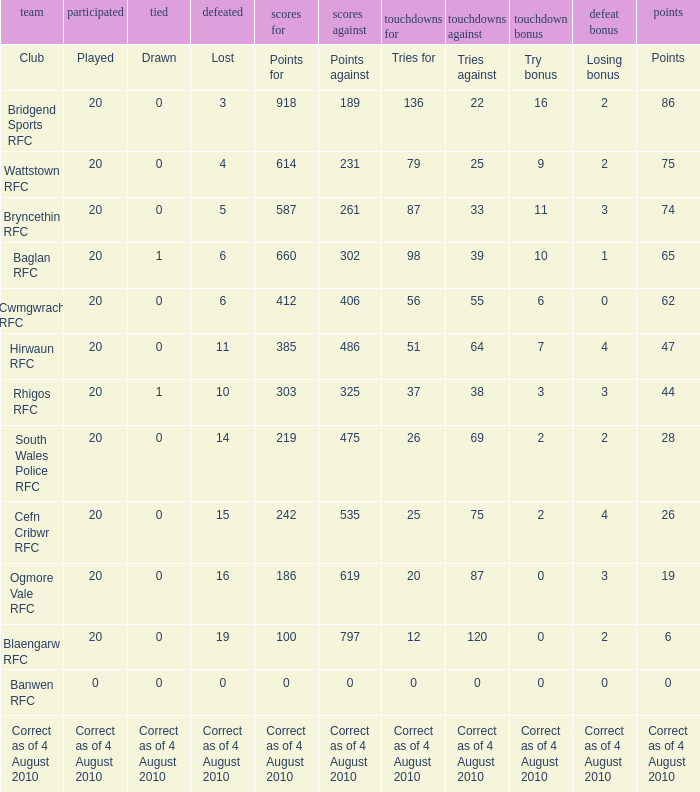Parse the table in full. {'header': ['team', 'participated', 'tied', 'defeated', 'scores for', 'scores against', 'touchdowns for', 'touchdowns against', 'touchdown bonus', 'defeat bonus', 'points'], 'rows': [['Club', 'Played', 'Drawn', 'Lost', 'Points for', 'Points against', 'Tries for', 'Tries against', 'Try bonus', 'Losing bonus', 'Points'], ['Bridgend Sports RFC', '20', '0', '3', '918', '189', '136', '22', '16', '2', '86'], ['Wattstown RFC', '20', '0', '4', '614', '231', '79', '25', '9', '2', '75'], ['Bryncethin RFC', '20', '0', '5', '587', '261', '87', '33', '11', '3', '74'], ['Baglan RFC', '20', '1', '6', '660', '302', '98', '39', '10', '1', '65'], ['Cwmgwrach RFC', '20', '0', '6', '412', '406', '56', '55', '6', '0', '62'], ['Hirwaun RFC', '20', '0', '11', '385', '486', '51', '64', '7', '4', '47'], ['Rhigos RFC', '20', '1', '10', '303', '325', '37', '38', '3', '3', '44'], ['South Wales Police RFC', '20', '0', '14', '219', '475', '26', '69', '2', '2', '28'], ['Cefn Cribwr RFC', '20', '0', '15', '242', '535', '25', '75', '2', '4', '26'], ['Ogmore Vale RFC', '20', '0', '16', '186', '619', '20', '87', '0', '3', '19'], ['Blaengarw RFC', '20', '0', '19', '100', '797', '12', '120', '0', '2', '6'], ['Banwen RFC', '0', '0', '0', '0', '0', '0', '0', '0', '0', '0'], ['Correct as of 4 August 2010', 'Correct as of 4 August 2010', 'Correct as of 4 August 2010', 'Correct as of 4 August 2010', 'Correct as of 4 August 2010', 'Correct as of 4 August 2010', 'Correct as of 4 August 2010', 'Correct as of 4 August 2010', 'Correct as of 4 August 2010', 'Correct as of 4 August 2010', 'Correct as of 4 August 2010']]} What is sketched when the club is hirwaun rfc? 0.0. 